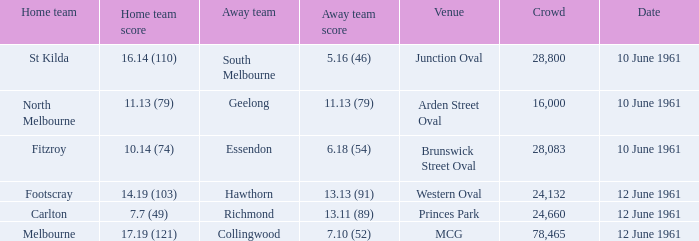What was the local team's score against the richmond away team? 7.7 (49). 